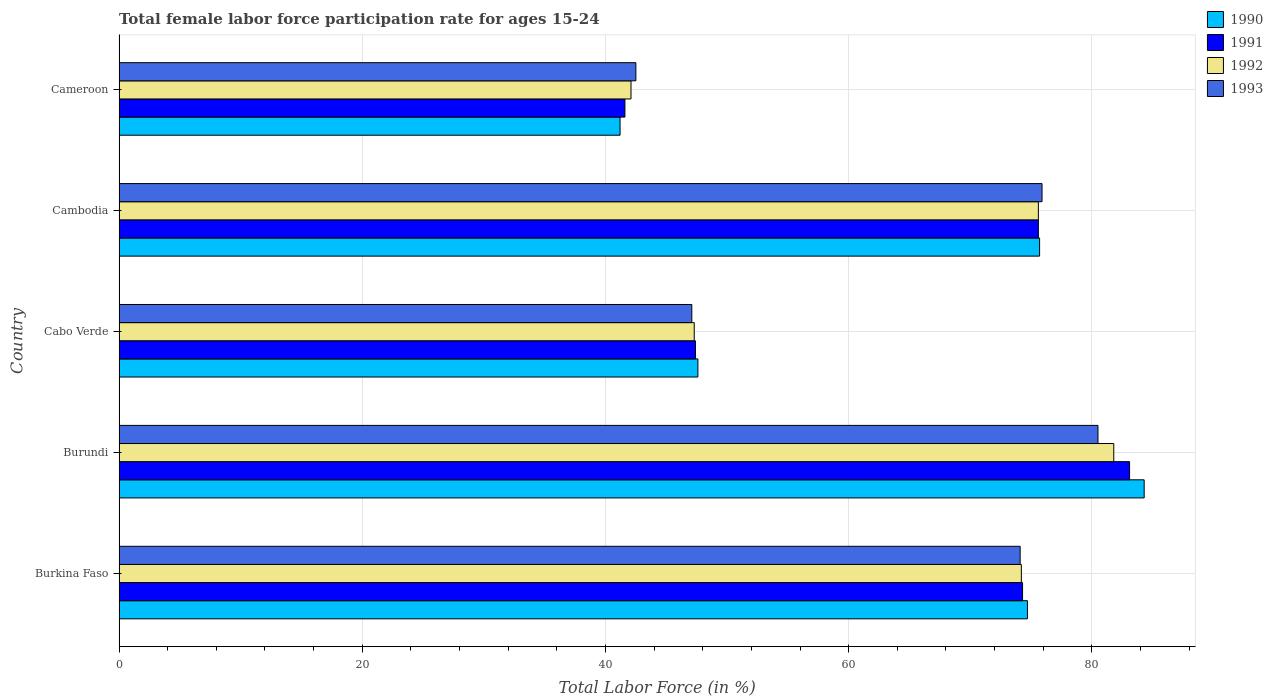How many different coloured bars are there?
Your answer should be very brief. 4. Are the number of bars per tick equal to the number of legend labels?
Ensure brevity in your answer.  Yes. How many bars are there on the 3rd tick from the top?
Provide a short and direct response. 4. What is the label of the 5th group of bars from the top?
Your answer should be compact. Burkina Faso. In how many cases, is the number of bars for a given country not equal to the number of legend labels?
Offer a very short reply. 0. What is the female labor force participation rate in 1990 in Cabo Verde?
Provide a succinct answer. 47.6. Across all countries, what is the maximum female labor force participation rate in 1992?
Your answer should be very brief. 81.8. Across all countries, what is the minimum female labor force participation rate in 1992?
Make the answer very short. 42.1. In which country was the female labor force participation rate in 1991 maximum?
Your answer should be very brief. Burundi. In which country was the female labor force participation rate in 1993 minimum?
Your answer should be very brief. Cameroon. What is the total female labor force participation rate in 1993 in the graph?
Make the answer very short. 320.1. What is the difference between the female labor force participation rate in 1990 in Burkina Faso and that in Cameroon?
Make the answer very short. 33.5. What is the difference between the female labor force participation rate in 1990 in Cambodia and the female labor force participation rate in 1991 in Burkina Faso?
Give a very brief answer. 1.4. What is the average female labor force participation rate in 1992 per country?
Give a very brief answer. 64.2. What is the difference between the female labor force participation rate in 1993 and female labor force participation rate in 1992 in Cameroon?
Provide a succinct answer. 0.4. In how many countries, is the female labor force participation rate in 1992 greater than 68 %?
Offer a terse response. 3. What is the ratio of the female labor force participation rate in 1993 in Burkina Faso to that in Cameroon?
Offer a terse response. 1.74. Is the female labor force participation rate in 1992 in Burkina Faso less than that in Cabo Verde?
Give a very brief answer. No. Is the difference between the female labor force participation rate in 1993 in Burundi and Cambodia greater than the difference between the female labor force participation rate in 1992 in Burundi and Cambodia?
Provide a short and direct response. No. What is the difference between the highest and the second highest female labor force participation rate in 1993?
Make the answer very short. 4.6. What is the difference between the highest and the lowest female labor force participation rate in 1993?
Give a very brief answer. 38. What does the 1st bar from the top in Burundi represents?
Provide a short and direct response. 1993. What does the 2nd bar from the bottom in Burundi represents?
Your answer should be compact. 1991. How many bars are there?
Ensure brevity in your answer.  20. Are all the bars in the graph horizontal?
Make the answer very short. Yes. How many countries are there in the graph?
Keep it short and to the point. 5. What is the difference between two consecutive major ticks on the X-axis?
Offer a very short reply. 20. Does the graph contain any zero values?
Make the answer very short. No. Where does the legend appear in the graph?
Your answer should be very brief. Top right. What is the title of the graph?
Provide a short and direct response. Total female labor force participation rate for ages 15-24. Does "1974" appear as one of the legend labels in the graph?
Ensure brevity in your answer.  No. What is the label or title of the X-axis?
Keep it short and to the point. Total Labor Force (in %). What is the label or title of the Y-axis?
Offer a terse response. Country. What is the Total Labor Force (in %) in 1990 in Burkina Faso?
Provide a short and direct response. 74.7. What is the Total Labor Force (in %) of 1991 in Burkina Faso?
Provide a succinct answer. 74.3. What is the Total Labor Force (in %) of 1992 in Burkina Faso?
Make the answer very short. 74.2. What is the Total Labor Force (in %) in 1993 in Burkina Faso?
Provide a short and direct response. 74.1. What is the Total Labor Force (in %) of 1990 in Burundi?
Your answer should be very brief. 84.3. What is the Total Labor Force (in %) of 1991 in Burundi?
Your response must be concise. 83.1. What is the Total Labor Force (in %) of 1992 in Burundi?
Give a very brief answer. 81.8. What is the Total Labor Force (in %) of 1993 in Burundi?
Give a very brief answer. 80.5. What is the Total Labor Force (in %) in 1990 in Cabo Verde?
Offer a terse response. 47.6. What is the Total Labor Force (in %) in 1991 in Cabo Verde?
Your answer should be very brief. 47.4. What is the Total Labor Force (in %) in 1992 in Cabo Verde?
Keep it short and to the point. 47.3. What is the Total Labor Force (in %) of 1993 in Cabo Verde?
Offer a terse response. 47.1. What is the Total Labor Force (in %) in 1990 in Cambodia?
Your answer should be very brief. 75.7. What is the Total Labor Force (in %) of 1991 in Cambodia?
Keep it short and to the point. 75.6. What is the Total Labor Force (in %) of 1992 in Cambodia?
Ensure brevity in your answer.  75.6. What is the Total Labor Force (in %) of 1993 in Cambodia?
Give a very brief answer. 75.9. What is the Total Labor Force (in %) of 1990 in Cameroon?
Offer a terse response. 41.2. What is the Total Labor Force (in %) of 1991 in Cameroon?
Your answer should be very brief. 41.6. What is the Total Labor Force (in %) in 1992 in Cameroon?
Provide a short and direct response. 42.1. What is the Total Labor Force (in %) of 1993 in Cameroon?
Provide a succinct answer. 42.5. Across all countries, what is the maximum Total Labor Force (in %) in 1990?
Keep it short and to the point. 84.3. Across all countries, what is the maximum Total Labor Force (in %) in 1991?
Your answer should be very brief. 83.1. Across all countries, what is the maximum Total Labor Force (in %) in 1992?
Provide a short and direct response. 81.8. Across all countries, what is the maximum Total Labor Force (in %) of 1993?
Offer a very short reply. 80.5. Across all countries, what is the minimum Total Labor Force (in %) of 1990?
Your answer should be very brief. 41.2. Across all countries, what is the minimum Total Labor Force (in %) in 1991?
Your response must be concise. 41.6. Across all countries, what is the minimum Total Labor Force (in %) of 1992?
Ensure brevity in your answer.  42.1. Across all countries, what is the minimum Total Labor Force (in %) in 1993?
Ensure brevity in your answer.  42.5. What is the total Total Labor Force (in %) in 1990 in the graph?
Offer a terse response. 323.5. What is the total Total Labor Force (in %) in 1991 in the graph?
Make the answer very short. 322. What is the total Total Labor Force (in %) of 1992 in the graph?
Your answer should be very brief. 321. What is the total Total Labor Force (in %) of 1993 in the graph?
Offer a very short reply. 320.1. What is the difference between the Total Labor Force (in %) of 1990 in Burkina Faso and that in Cabo Verde?
Give a very brief answer. 27.1. What is the difference between the Total Labor Force (in %) in 1991 in Burkina Faso and that in Cabo Verde?
Offer a very short reply. 26.9. What is the difference between the Total Labor Force (in %) of 1992 in Burkina Faso and that in Cabo Verde?
Give a very brief answer. 26.9. What is the difference between the Total Labor Force (in %) of 1993 in Burkina Faso and that in Cabo Verde?
Your answer should be very brief. 27. What is the difference between the Total Labor Force (in %) in 1991 in Burkina Faso and that in Cambodia?
Provide a short and direct response. -1.3. What is the difference between the Total Labor Force (in %) of 1992 in Burkina Faso and that in Cambodia?
Give a very brief answer. -1.4. What is the difference between the Total Labor Force (in %) in 1993 in Burkina Faso and that in Cambodia?
Provide a short and direct response. -1.8. What is the difference between the Total Labor Force (in %) in 1990 in Burkina Faso and that in Cameroon?
Provide a succinct answer. 33.5. What is the difference between the Total Labor Force (in %) in 1991 in Burkina Faso and that in Cameroon?
Provide a succinct answer. 32.7. What is the difference between the Total Labor Force (in %) of 1992 in Burkina Faso and that in Cameroon?
Make the answer very short. 32.1. What is the difference between the Total Labor Force (in %) in 1993 in Burkina Faso and that in Cameroon?
Your answer should be compact. 31.6. What is the difference between the Total Labor Force (in %) of 1990 in Burundi and that in Cabo Verde?
Give a very brief answer. 36.7. What is the difference between the Total Labor Force (in %) in 1991 in Burundi and that in Cabo Verde?
Ensure brevity in your answer.  35.7. What is the difference between the Total Labor Force (in %) in 1992 in Burundi and that in Cabo Verde?
Offer a very short reply. 34.5. What is the difference between the Total Labor Force (in %) of 1993 in Burundi and that in Cabo Verde?
Make the answer very short. 33.4. What is the difference between the Total Labor Force (in %) of 1991 in Burundi and that in Cambodia?
Offer a terse response. 7.5. What is the difference between the Total Labor Force (in %) in 1992 in Burundi and that in Cambodia?
Your response must be concise. 6.2. What is the difference between the Total Labor Force (in %) of 1990 in Burundi and that in Cameroon?
Ensure brevity in your answer.  43.1. What is the difference between the Total Labor Force (in %) of 1991 in Burundi and that in Cameroon?
Your answer should be compact. 41.5. What is the difference between the Total Labor Force (in %) in 1992 in Burundi and that in Cameroon?
Give a very brief answer. 39.7. What is the difference between the Total Labor Force (in %) of 1990 in Cabo Verde and that in Cambodia?
Make the answer very short. -28.1. What is the difference between the Total Labor Force (in %) in 1991 in Cabo Verde and that in Cambodia?
Provide a succinct answer. -28.2. What is the difference between the Total Labor Force (in %) of 1992 in Cabo Verde and that in Cambodia?
Ensure brevity in your answer.  -28.3. What is the difference between the Total Labor Force (in %) of 1993 in Cabo Verde and that in Cambodia?
Provide a short and direct response. -28.8. What is the difference between the Total Labor Force (in %) in 1991 in Cabo Verde and that in Cameroon?
Your response must be concise. 5.8. What is the difference between the Total Labor Force (in %) in 1990 in Cambodia and that in Cameroon?
Your response must be concise. 34.5. What is the difference between the Total Labor Force (in %) of 1991 in Cambodia and that in Cameroon?
Provide a short and direct response. 34. What is the difference between the Total Labor Force (in %) in 1992 in Cambodia and that in Cameroon?
Keep it short and to the point. 33.5. What is the difference between the Total Labor Force (in %) in 1993 in Cambodia and that in Cameroon?
Make the answer very short. 33.4. What is the difference between the Total Labor Force (in %) in 1990 in Burkina Faso and the Total Labor Force (in %) in 1991 in Burundi?
Provide a short and direct response. -8.4. What is the difference between the Total Labor Force (in %) of 1990 in Burkina Faso and the Total Labor Force (in %) of 1992 in Burundi?
Provide a short and direct response. -7.1. What is the difference between the Total Labor Force (in %) in 1990 in Burkina Faso and the Total Labor Force (in %) in 1993 in Burundi?
Provide a short and direct response. -5.8. What is the difference between the Total Labor Force (in %) of 1991 in Burkina Faso and the Total Labor Force (in %) of 1993 in Burundi?
Your answer should be very brief. -6.2. What is the difference between the Total Labor Force (in %) in 1992 in Burkina Faso and the Total Labor Force (in %) in 1993 in Burundi?
Your answer should be very brief. -6.3. What is the difference between the Total Labor Force (in %) of 1990 in Burkina Faso and the Total Labor Force (in %) of 1991 in Cabo Verde?
Ensure brevity in your answer.  27.3. What is the difference between the Total Labor Force (in %) in 1990 in Burkina Faso and the Total Labor Force (in %) in 1992 in Cabo Verde?
Offer a terse response. 27.4. What is the difference between the Total Labor Force (in %) of 1990 in Burkina Faso and the Total Labor Force (in %) of 1993 in Cabo Verde?
Keep it short and to the point. 27.6. What is the difference between the Total Labor Force (in %) of 1991 in Burkina Faso and the Total Labor Force (in %) of 1992 in Cabo Verde?
Provide a succinct answer. 27. What is the difference between the Total Labor Force (in %) of 1991 in Burkina Faso and the Total Labor Force (in %) of 1993 in Cabo Verde?
Your answer should be compact. 27.2. What is the difference between the Total Labor Force (in %) in 1992 in Burkina Faso and the Total Labor Force (in %) in 1993 in Cabo Verde?
Provide a short and direct response. 27.1. What is the difference between the Total Labor Force (in %) of 1990 in Burkina Faso and the Total Labor Force (in %) of 1991 in Cambodia?
Ensure brevity in your answer.  -0.9. What is the difference between the Total Labor Force (in %) of 1990 in Burkina Faso and the Total Labor Force (in %) of 1993 in Cambodia?
Your answer should be very brief. -1.2. What is the difference between the Total Labor Force (in %) in 1991 in Burkina Faso and the Total Labor Force (in %) in 1993 in Cambodia?
Your answer should be very brief. -1.6. What is the difference between the Total Labor Force (in %) in 1990 in Burkina Faso and the Total Labor Force (in %) in 1991 in Cameroon?
Keep it short and to the point. 33.1. What is the difference between the Total Labor Force (in %) of 1990 in Burkina Faso and the Total Labor Force (in %) of 1992 in Cameroon?
Ensure brevity in your answer.  32.6. What is the difference between the Total Labor Force (in %) of 1990 in Burkina Faso and the Total Labor Force (in %) of 1993 in Cameroon?
Keep it short and to the point. 32.2. What is the difference between the Total Labor Force (in %) in 1991 in Burkina Faso and the Total Labor Force (in %) in 1992 in Cameroon?
Ensure brevity in your answer.  32.2. What is the difference between the Total Labor Force (in %) in 1991 in Burkina Faso and the Total Labor Force (in %) in 1993 in Cameroon?
Make the answer very short. 31.8. What is the difference between the Total Labor Force (in %) in 1992 in Burkina Faso and the Total Labor Force (in %) in 1993 in Cameroon?
Ensure brevity in your answer.  31.7. What is the difference between the Total Labor Force (in %) of 1990 in Burundi and the Total Labor Force (in %) of 1991 in Cabo Verde?
Keep it short and to the point. 36.9. What is the difference between the Total Labor Force (in %) in 1990 in Burundi and the Total Labor Force (in %) in 1993 in Cabo Verde?
Give a very brief answer. 37.2. What is the difference between the Total Labor Force (in %) of 1991 in Burundi and the Total Labor Force (in %) of 1992 in Cabo Verde?
Provide a succinct answer. 35.8. What is the difference between the Total Labor Force (in %) in 1991 in Burundi and the Total Labor Force (in %) in 1993 in Cabo Verde?
Make the answer very short. 36. What is the difference between the Total Labor Force (in %) of 1992 in Burundi and the Total Labor Force (in %) of 1993 in Cabo Verde?
Offer a terse response. 34.7. What is the difference between the Total Labor Force (in %) in 1991 in Burundi and the Total Labor Force (in %) in 1992 in Cambodia?
Make the answer very short. 7.5. What is the difference between the Total Labor Force (in %) of 1992 in Burundi and the Total Labor Force (in %) of 1993 in Cambodia?
Your answer should be compact. 5.9. What is the difference between the Total Labor Force (in %) in 1990 in Burundi and the Total Labor Force (in %) in 1991 in Cameroon?
Your response must be concise. 42.7. What is the difference between the Total Labor Force (in %) in 1990 in Burundi and the Total Labor Force (in %) in 1992 in Cameroon?
Your answer should be very brief. 42.2. What is the difference between the Total Labor Force (in %) in 1990 in Burundi and the Total Labor Force (in %) in 1993 in Cameroon?
Make the answer very short. 41.8. What is the difference between the Total Labor Force (in %) of 1991 in Burundi and the Total Labor Force (in %) of 1992 in Cameroon?
Provide a short and direct response. 41. What is the difference between the Total Labor Force (in %) of 1991 in Burundi and the Total Labor Force (in %) of 1993 in Cameroon?
Your response must be concise. 40.6. What is the difference between the Total Labor Force (in %) in 1992 in Burundi and the Total Labor Force (in %) in 1993 in Cameroon?
Offer a terse response. 39.3. What is the difference between the Total Labor Force (in %) of 1990 in Cabo Verde and the Total Labor Force (in %) of 1991 in Cambodia?
Make the answer very short. -28. What is the difference between the Total Labor Force (in %) in 1990 in Cabo Verde and the Total Labor Force (in %) in 1993 in Cambodia?
Your response must be concise. -28.3. What is the difference between the Total Labor Force (in %) of 1991 in Cabo Verde and the Total Labor Force (in %) of 1992 in Cambodia?
Keep it short and to the point. -28.2. What is the difference between the Total Labor Force (in %) of 1991 in Cabo Verde and the Total Labor Force (in %) of 1993 in Cambodia?
Keep it short and to the point. -28.5. What is the difference between the Total Labor Force (in %) of 1992 in Cabo Verde and the Total Labor Force (in %) of 1993 in Cambodia?
Your answer should be very brief. -28.6. What is the difference between the Total Labor Force (in %) of 1990 in Cabo Verde and the Total Labor Force (in %) of 1993 in Cameroon?
Offer a very short reply. 5.1. What is the difference between the Total Labor Force (in %) of 1992 in Cabo Verde and the Total Labor Force (in %) of 1993 in Cameroon?
Your response must be concise. 4.8. What is the difference between the Total Labor Force (in %) of 1990 in Cambodia and the Total Labor Force (in %) of 1991 in Cameroon?
Offer a very short reply. 34.1. What is the difference between the Total Labor Force (in %) in 1990 in Cambodia and the Total Labor Force (in %) in 1992 in Cameroon?
Offer a terse response. 33.6. What is the difference between the Total Labor Force (in %) in 1990 in Cambodia and the Total Labor Force (in %) in 1993 in Cameroon?
Your response must be concise. 33.2. What is the difference between the Total Labor Force (in %) in 1991 in Cambodia and the Total Labor Force (in %) in 1992 in Cameroon?
Provide a succinct answer. 33.5. What is the difference between the Total Labor Force (in %) of 1991 in Cambodia and the Total Labor Force (in %) of 1993 in Cameroon?
Make the answer very short. 33.1. What is the difference between the Total Labor Force (in %) in 1992 in Cambodia and the Total Labor Force (in %) in 1993 in Cameroon?
Your answer should be very brief. 33.1. What is the average Total Labor Force (in %) of 1990 per country?
Give a very brief answer. 64.7. What is the average Total Labor Force (in %) in 1991 per country?
Your response must be concise. 64.4. What is the average Total Labor Force (in %) of 1992 per country?
Your answer should be very brief. 64.2. What is the average Total Labor Force (in %) in 1993 per country?
Your response must be concise. 64.02. What is the difference between the Total Labor Force (in %) of 1992 and Total Labor Force (in %) of 1993 in Burkina Faso?
Offer a terse response. 0.1. What is the difference between the Total Labor Force (in %) in 1991 and Total Labor Force (in %) in 1992 in Burundi?
Give a very brief answer. 1.3. What is the difference between the Total Labor Force (in %) of 1992 and Total Labor Force (in %) of 1993 in Burundi?
Offer a very short reply. 1.3. What is the difference between the Total Labor Force (in %) of 1990 and Total Labor Force (in %) of 1991 in Cabo Verde?
Your response must be concise. 0.2. What is the difference between the Total Labor Force (in %) in 1990 and Total Labor Force (in %) in 1992 in Cabo Verde?
Offer a very short reply. 0.3. What is the difference between the Total Labor Force (in %) in 1991 and Total Labor Force (in %) in 1993 in Cabo Verde?
Your response must be concise. 0.3. What is the difference between the Total Labor Force (in %) of 1992 and Total Labor Force (in %) of 1993 in Cabo Verde?
Provide a succinct answer. 0.2. What is the difference between the Total Labor Force (in %) in 1990 and Total Labor Force (in %) in 1991 in Cambodia?
Your answer should be compact. 0.1. What is the difference between the Total Labor Force (in %) of 1990 and Total Labor Force (in %) of 1992 in Cambodia?
Make the answer very short. 0.1. What is the difference between the Total Labor Force (in %) in 1991 and Total Labor Force (in %) in 1993 in Cambodia?
Offer a terse response. -0.3. What is the difference between the Total Labor Force (in %) of 1992 and Total Labor Force (in %) of 1993 in Cambodia?
Ensure brevity in your answer.  -0.3. What is the difference between the Total Labor Force (in %) in 1990 and Total Labor Force (in %) in 1991 in Cameroon?
Offer a terse response. -0.4. What is the difference between the Total Labor Force (in %) in 1990 and Total Labor Force (in %) in 1992 in Cameroon?
Your answer should be compact. -0.9. What is the difference between the Total Labor Force (in %) of 1991 and Total Labor Force (in %) of 1992 in Cameroon?
Your answer should be compact. -0.5. What is the ratio of the Total Labor Force (in %) of 1990 in Burkina Faso to that in Burundi?
Give a very brief answer. 0.89. What is the ratio of the Total Labor Force (in %) in 1991 in Burkina Faso to that in Burundi?
Give a very brief answer. 0.89. What is the ratio of the Total Labor Force (in %) in 1992 in Burkina Faso to that in Burundi?
Give a very brief answer. 0.91. What is the ratio of the Total Labor Force (in %) in 1993 in Burkina Faso to that in Burundi?
Your answer should be very brief. 0.92. What is the ratio of the Total Labor Force (in %) of 1990 in Burkina Faso to that in Cabo Verde?
Your response must be concise. 1.57. What is the ratio of the Total Labor Force (in %) of 1991 in Burkina Faso to that in Cabo Verde?
Keep it short and to the point. 1.57. What is the ratio of the Total Labor Force (in %) in 1992 in Burkina Faso to that in Cabo Verde?
Give a very brief answer. 1.57. What is the ratio of the Total Labor Force (in %) of 1993 in Burkina Faso to that in Cabo Verde?
Your answer should be compact. 1.57. What is the ratio of the Total Labor Force (in %) in 1990 in Burkina Faso to that in Cambodia?
Give a very brief answer. 0.99. What is the ratio of the Total Labor Force (in %) in 1991 in Burkina Faso to that in Cambodia?
Make the answer very short. 0.98. What is the ratio of the Total Labor Force (in %) of 1992 in Burkina Faso to that in Cambodia?
Keep it short and to the point. 0.98. What is the ratio of the Total Labor Force (in %) of 1993 in Burkina Faso to that in Cambodia?
Ensure brevity in your answer.  0.98. What is the ratio of the Total Labor Force (in %) of 1990 in Burkina Faso to that in Cameroon?
Keep it short and to the point. 1.81. What is the ratio of the Total Labor Force (in %) in 1991 in Burkina Faso to that in Cameroon?
Ensure brevity in your answer.  1.79. What is the ratio of the Total Labor Force (in %) of 1992 in Burkina Faso to that in Cameroon?
Your answer should be compact. 1.76. What is the ratio of the Total Labor Force (in %) of 1993 in Burkina Faso to that in Cameroon?
Provide a succinct answer. 1.74. What is the ratio of the Total Labor Force (in %) of 1990 in Burundi to that in Cabo Verde?
Ensure brevity in your answer.  1.77. What is the ratio of the Total Labor Force (in %) in 1991 in Burundi to that in Cabo Verde?
Provide a succinct answer. 1.75. What is the ratio of the Total Labor Force (in %) of 1992 in Burundi to that in Cabo Verde?
Your answer should be very brief. 1.73. What is the ratio of the Total Labor Force (in %) of 1993 in Burundi to that in Cabo Verde?
Offer a very short reply. 1.71. What is the ratio of the Total Labor Force (in %) in 1990 in Burundi to that in Cambodia?
Provide a succinct answer. 1.11. What is the ratio of the Total Labor Force (in %) in 1991 in Burundi to that in Cambodia?
Your answer should be very brief. 1.1. What is the ratio of the Total Labor Force (in %) in 1992 in Burundi to that in Cambodia?
Ensure brevity in your answer.  1.08. What is the ratio of the Total Labor Force (in %) of 1993 in Burundi to that in Cambodia?
Offer a very short reply. 1.06. What is the ratio of the Total Labor Force (in %) in 1990 in Burundi to that in Cameroon?
Keep it short and to the point. 2.05. What is the ratio of the Total Labor Force (in %) in 1991 in Burundi to that in Cameroon?
Your response must be concise. 2. What is the ratio of the Total Labor Force (in %) in 1992 in Burundi to that in Cameroon?
Your answer should be very brief. 1.94. What is the ratio of the Total Labor Force (in %) of 1993 in Burundi to that in Cameroon?
Your answer should be compact. 1.89. What is the ratio of the Total Labor Force (in %) of 1990 in Cabo Verde to that in Cambodia?
Make the answer very short. 0.63. What is the ratio of the Total Labor Force (in %) of 1991 in Cabo Verde to that in Cambodia?
Provide a succinct answer. 0.63. What is the ratio of the Total Labor Force (in %) of 1992 in Cabo Verde to that in Cambodia?
Your answer should be very brief. 0.63. What is the ratio of the Total Labor Force (in %) of 1993 in Cabo Verde to that in Cambodia?
Provide a short and direct response. 0.62. What is the ratio of the Total Labor Force (in %) in 1990 in Cabo Verde to that in Cameroon?
Provide a short and direct response. 1.16. What is the ratio of the Total Labor Force (in %) in 1991 in Cabo Verde to that in Cameroon?
Ensure brevity in your answer.  1.14. What is the ratio of the Total Labor Force (in %) in 1992 in Cabo Verde to that in Cameroon?
Offer a very short reply. 1.12. What is the ratio of the Total Labor Force (in %) of 1993 in Cabo Verde to that in Cameroon?
Provide a succinct answer. 1.11. What is the ratio of the Total Labor Force (in %) in 1990 in Cambodia to that in Cameroon?
Give a very brief answer. 1.84. What is the ratio of the Total Labor Force (in %) in 1991 in Cambodia to that in Cameroon?
Your answer should be very brief. 1.82. What is the ratio of the Total Labor Force (in %) of 1992 in Cambodia to that in Cameroon?
Provide a short and direct response. 1.8. What is the ratio of the Total Labor Force (in %) in 1993 in Cambodia to that in Cameroon?
Your response must be concise. 1.79. What is the difference between the highest and the second highest Total Labor Force (in %) of 1990?
Offer a terse response. 8.6. What is the difference between the highest and the second highest Total Labor Force (in %) in 1991?
Ensure brevity in your answer.  7.5. What is the difference between the highest and the second highest Total Labor Force (in %) in 1993?
Your response must be concise. 4.6. What is the difference between the highest and the lowest Total Labor Force (in %) of 1990?
Your response must be concise. 43.1. What is the difference between the highest and the lowest Total Labor Force (in %) of 1991?
Offer a very short reply. 41.5. What is the difference between the highest and the lowest Total Labor Force (in %) of 1992?
Give a very brief answer. 39.7. What is the difference between the highest and the lowest Total Labor Force (in %) of 1993?
Provide a succinct answer. 38. 